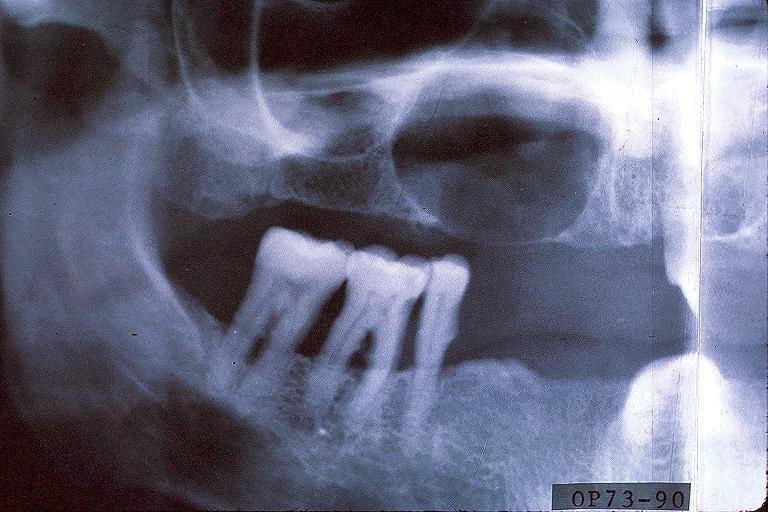does this image show cyst?
Answer the question using a single word or phrase. Yes 